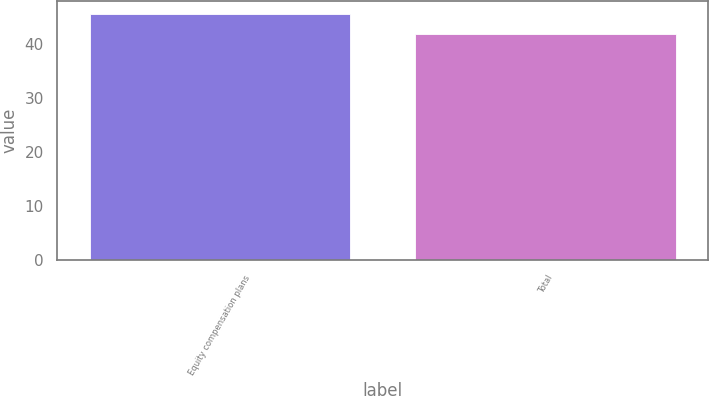Convert chart. <chart><loc_0><loc_0><loc_500><loc_500><bar_chart><fcel>Equity compensation plans<fcel>Total<nl><fcel>45.64<fcel>41.88<nl></chart> 